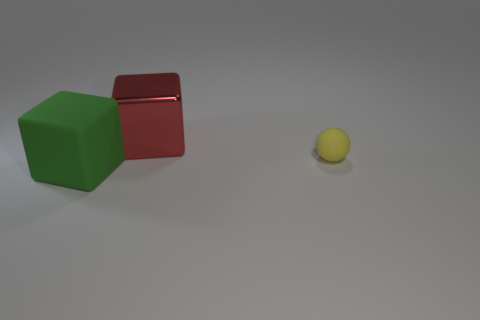Subtract all green blocks. Subtract all blue cylinders. How many blocks are left? 1 Subtract all blue balls. How many yellow blocks are left? 0 Add 2 big objects. How many reds exist? 0 Subtract all large yellow things. Subtract all yellow matte spheres. How many objects are left? 2 Add 2 big metallic things. How many big metallic things are left? 3 Add 2 metal objects. How many metal objects exist? 3 Add 3 tiny yellow matte balls. How many objects exist? 6 Subtract all green blocks. How many blocks are left? 1 Subtract 0 cyan cylinders. How many objects are left? 3 Subtract all cubes. How many objects are left? 1 